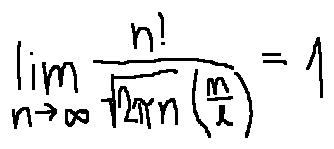Convert formula to latex. <formula><loc_0><loc_0><loc_500><loc_500>\lim \lim i t s _ { n \rightarrow \infty } \frac { n ! } { \sqrt { 2 \pi n } ( \frac { n } { e } ) } = 1</formula> 